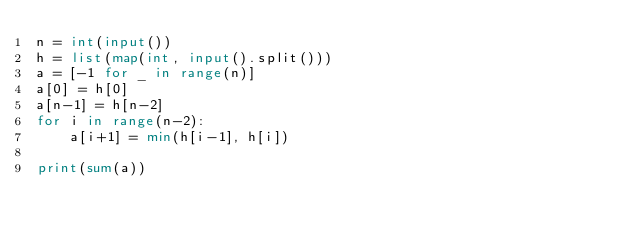<code> <loc_0><loc_0><loc_500><loc_500><_Python_>n = int(input())
h = list(map(int, input().split()))
a = [-1 for _ in range(n)]
a[0] = h[0]
a[n-1] = h[n-2]
for i in range(n-2):
	a[i+1] = min(h[i-1], h[i])

print(sum(a))</code> 